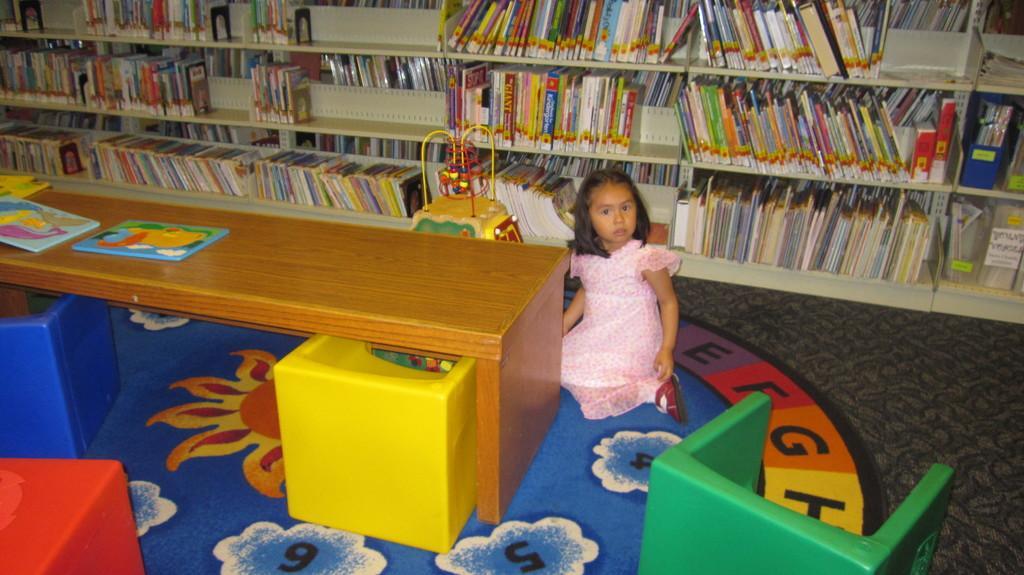Please provide a concise description of this image. In the picture we can see a kid wearing pink color dress sitting on ground and there are some things on table and in the background there are some books arranged in shelves. 